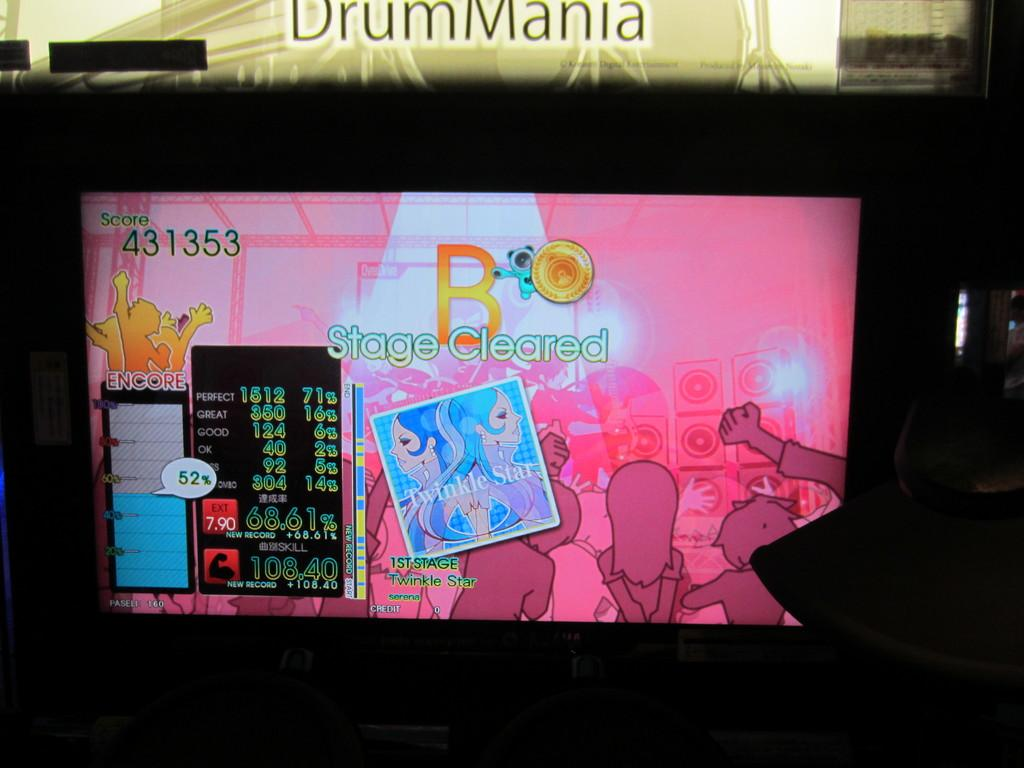<image>
Offer a succinct explanation of the picture presented. The game shown on the screen is saying the stage is cleared. 